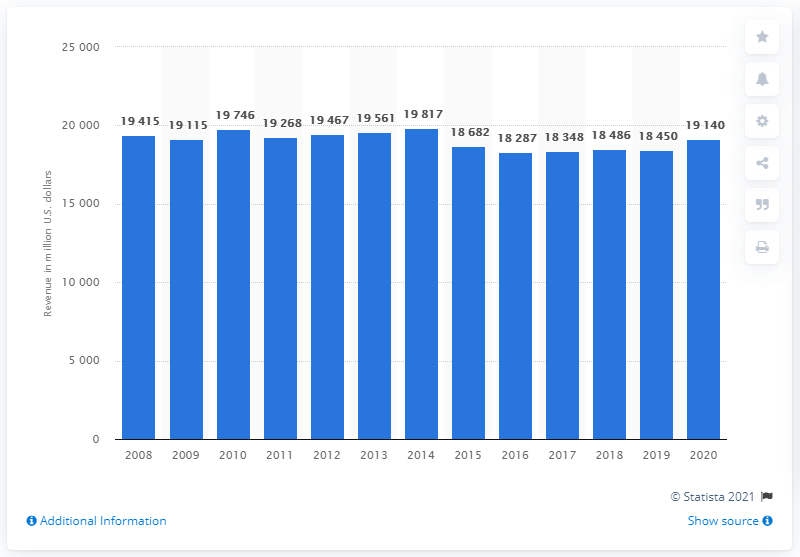Draw attention to some important aspects in this diagram. In 2020, Kimberly-Clark's annual revenue in the U.S. was approximately 19,140. 